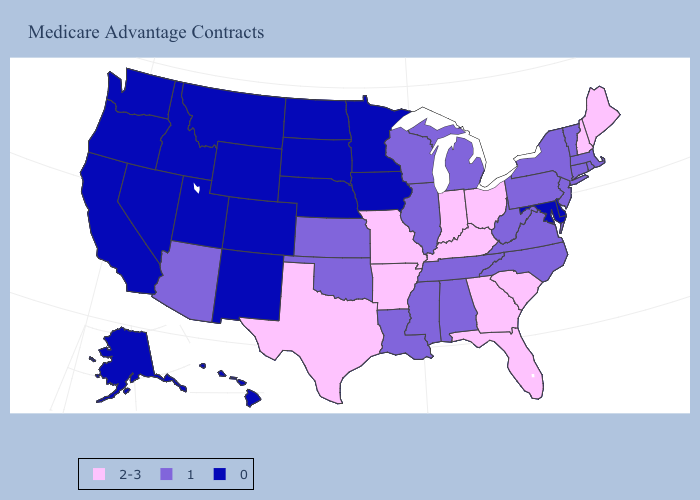What is the value of West Virginia?
Keep it brief. 1. Does Montana have the lowest value in the USA?
Answer briefly. Yes. Which states have the highest value in the USA?
Keep it brief. Arkansas, Florida, Georgia, Indiana, Kentucky, Maine, Missouri, New Hampshire, Ohio, South Carolina, Texas. Name the states that have a value in the range 1?
Short answer required. Alabama, Arizona, Connecticut, Illinois, Kansas, Louisiana, Massachusetts, Michigan, Mississippi, New Jersey, New York, North Carolina, Oklahoma, Pennsylvania, Rhode Island, Tennessee, Vermont, Virginia, West Virginia, Wisconsin. Which states have the lowest value in the USA?
Concise answer only. Alaska, California, Colorado, Delaware, Hawaii, Idaho, Iowa, Maryland, Minnesota, Montana, Nebraska, Nevada, New Mexico, North Dakota, Oregon, South Dakota, Utah, Washington, Wyoming. What is the value of South Carolina?
Quick response, please. 2-3. Does Alaska have a lower value than Wyoming?
Give a very brief answer. No. What is the value of Washington?
Answer briefly. 0. Does Florida have a higher value than North Dakota?
Give a very brief answer. Yes. Does the map have missing data?
Keep it brief. No. Among the states that border Louisiana , does Mississippi have the lowest value?
Write a very short answer. Yes. Does Tennessee have the lowest value in the USA?
Answer briefly. No. Does Minnesota have a lower value than California?
Quick response, please. No. 